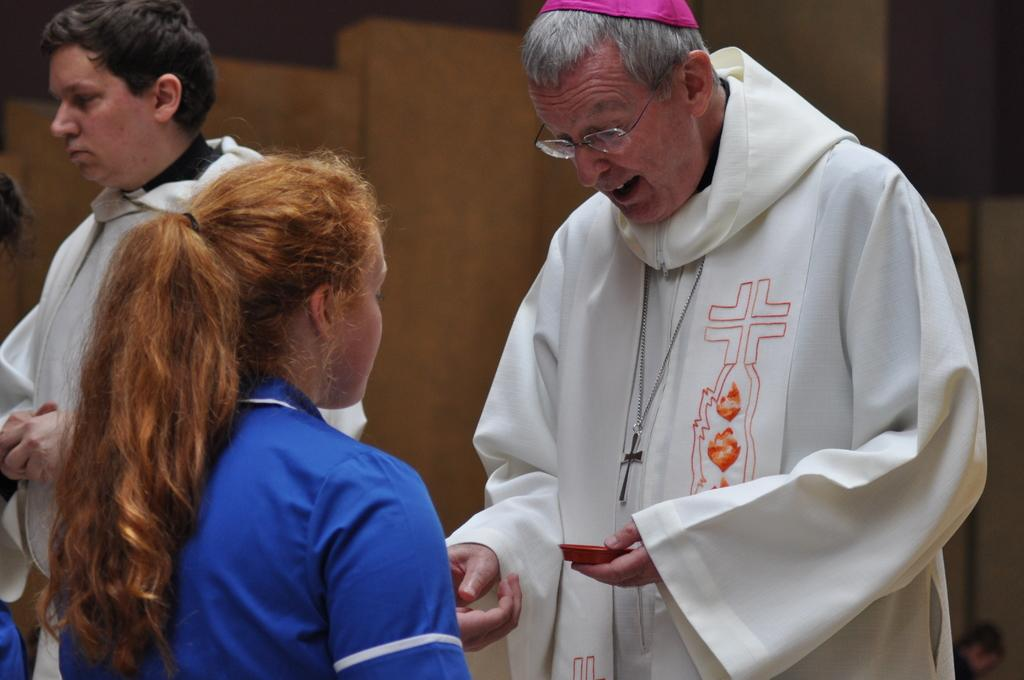How many people are in the image? There is a group of people in the image. Where are the people located in the image? The people are standing on a path. Can you describe the man in the group? The man in the group is wearing a white dress. What is the man holding in the image? The man is holding an object. What can be seen behind the people in the image? There is an object visible behind the people. How would you describe the lighting in the image? The background of the image is dark. What type of apparel is the man wearing to show respect in the image? The man is not wearing any specific apparel to show respect in the image; he is simply wearing a white dress. What is the man using the hammer for in the image? There is no hammer present in the image, so it cannot be determined what the man might be using it for. 